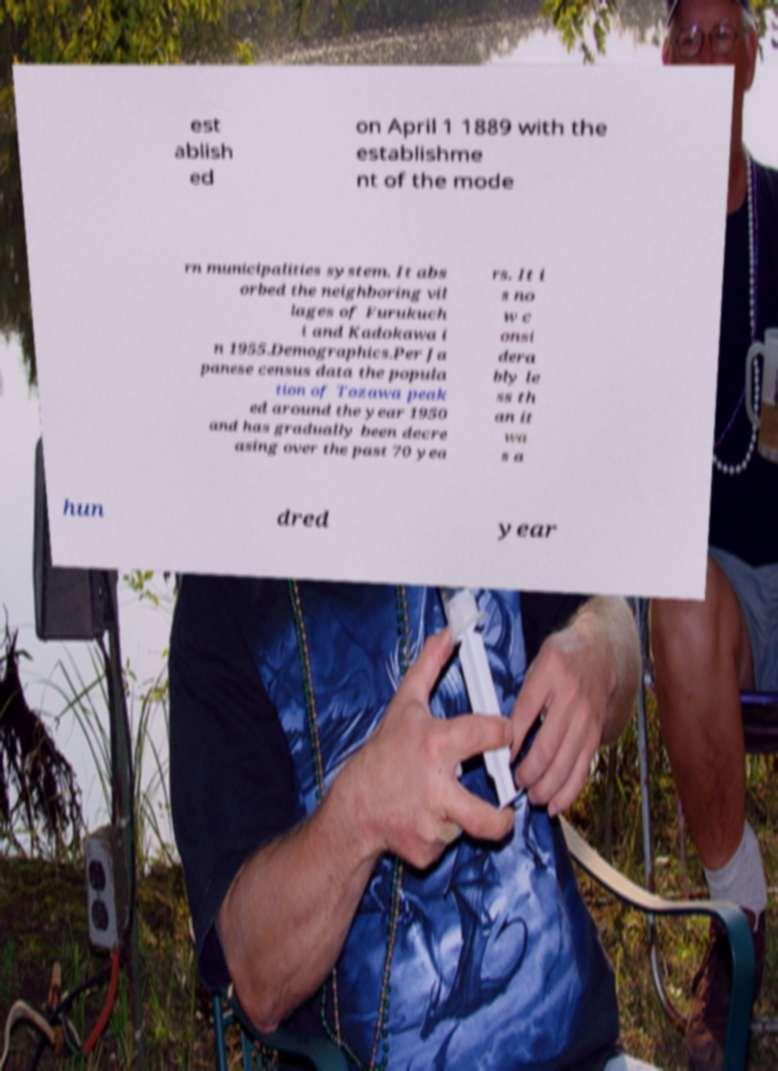Please identify and transcribe the text found in this image. est ablish ed on April 1 1889 with the establishme nt of the mode rn municipalities system. It abs orbed the neighboring vil lages of Furukuch i and Kadokawa i n 1955.Demographics.Per Ja panese census data the popula tion of Tozawa peak ed around the year 1950 and has gradually been decre asing over the past 70 yea rs. It i s no w c onsi dera bly le ss th an it wa s a hun dred year 